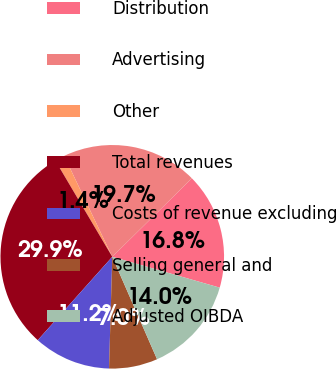Convert chart to OTSL. <chart><loc_0><loc_0><loc_500><loc_500><pie_chart><fcel>Distribution<fcel>Advertising<fcel>Other<fcel>Total revenues<fcel>Costs of revenue excluding<fcel>Selling general and<fcel>Adjusted OIBDA<nl><fcel>16.84%<fcel>19.69%<fcel>1.42%<fcel>29.89%<fcel>11.15%<fcel>7.02%<fcel>13.99%<nl></chart> 